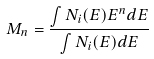Convert formula to latex. <formula><loc_0><loc_0><loc_500><loc_500>M _ { n } = \frac { \int N _ { i } ( E ) E ^ { n } d E } { \int N _ { i } ( E ) d E }</formula> 